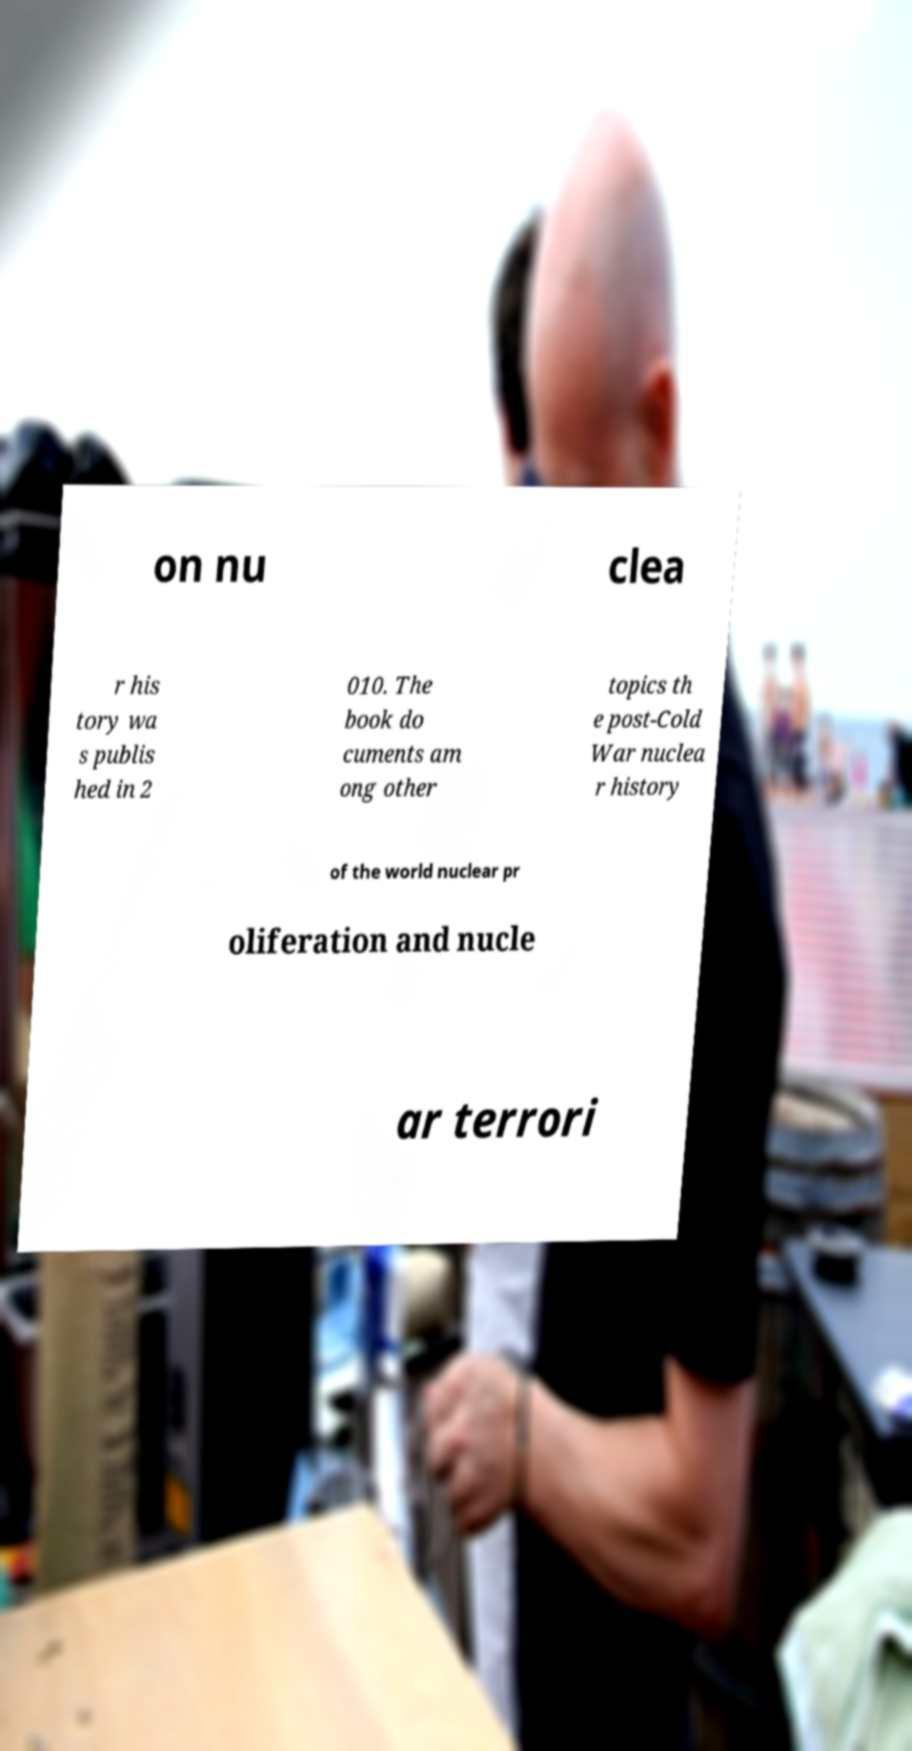Could you extract and type out the text from this image? on nu clea r his tory wa s publis hed in 2 010. The book do cuments am ong other topics th e post-Cold War nuclea r history of the world nuclear pr oliferation and nucle ar terrori 